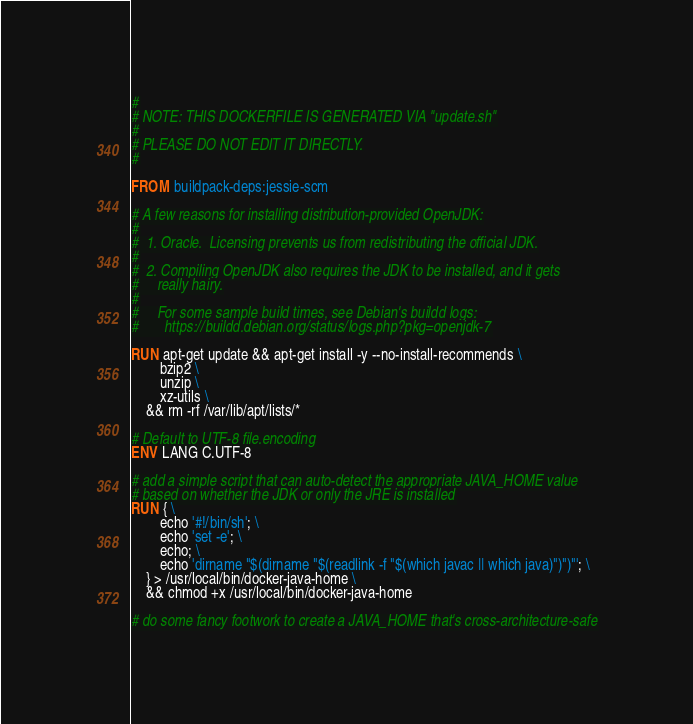Convert code to text. <code><loc_0><loc_0><loc_500><loc_500><_Dockerfile_>#
# NOTE: THIS DOCKERFILE IS GENERATED VIA "update.sh"
#
# PLEASE DO NOT EDIT IT DIRECTLY.
#

FROM buildpack-deps:jessie-scm

# A few reasons for installing distribution-provided OpenJDK:
#
#  1. Oracle.  Licensing prevents us from redistributing the official JDK.
#
#  2. Compiling OpenJDK also requires the JDK to be installed, and it gets
#     really hairy.
#
#     For some sample build times, see Debian's buildd logs:
#       https://buildd.debian.org/status/logs.php?pkg=openjdk-7

RUN apt-get update && apt-get install -y --no-install-recommends \
		bzip2 \
		unzip \
		xz-utils \
	&& rm -rf /var/lib/apt/lists/*

# Default to UTF-8 file.encoding
ENV LANG C.UTF-8

# add a simple script that can auto-detect the appropriate JAVA_HOME value
# based on whether the JDK or only the JRE is installed
RUN { \
		echo '#!/bin/sh'; \
		echo 'set -e'; \
		echo; \
		echo 'dirname "$(dirname "$(readlink -f "$(which javac || which java)")")"'; \
	} > /usr/local/bin/docker-java-home \
	&& chmod +x /usr/local/bin/docker-java-home

# do some fancy footwork to create a JAVA_HOME that's cross-architecture-safe</code> 